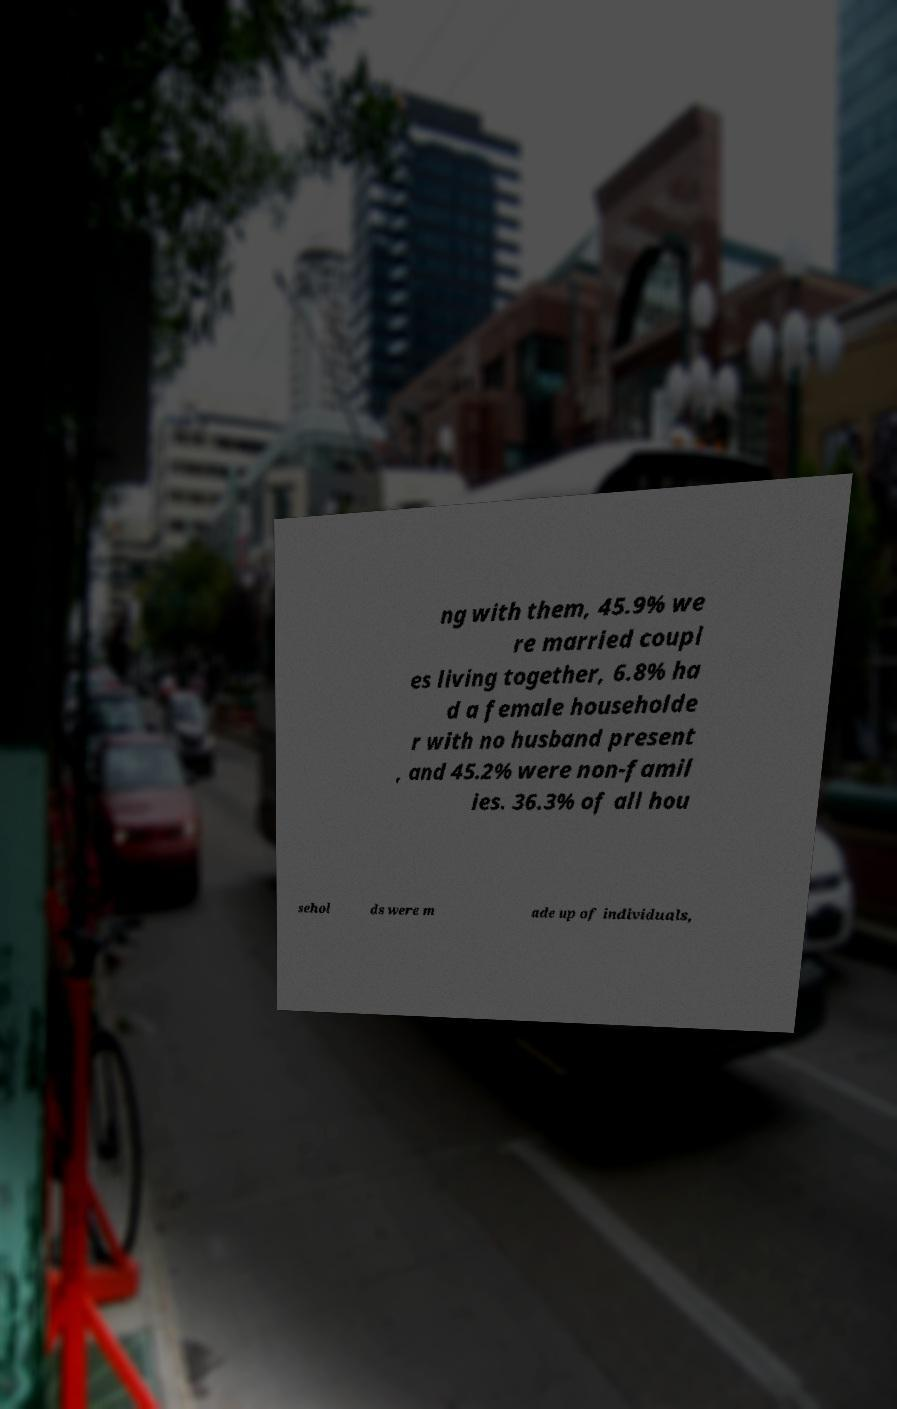For documentation purposes, I need the text within this image transcribed. Could you provide that? ng with them, 45.9% we re married coupl es living together, 6.8% ha d a female householde r with no husband present , and 45.2% were non-famil ies. 36.3% of all hou sehol ds were m ade up of individuals, 